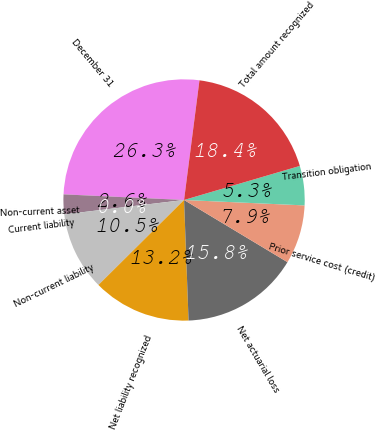Convert chart. <chart><loc_0><loc_0><loc_500><loc_500><pie_chart><fcel>December 31<fcel>Non-current asset<fcel>Current liability<fcel>Non-current liability<fcel>Net liability recognized<fcel>Net actuarial loss<fcel>Prior service cost (credit)<fcel>Transition obligation<fcel>Total amount recognized<nl><fcel>26.3%<fcel>2.64%<fcel>0.01%<fcel>10.53%<fcel>13.16%<fcel>15.79%<fcel>7.9%<fcel>5.27%<fcel>18.41%<nl></chart> 